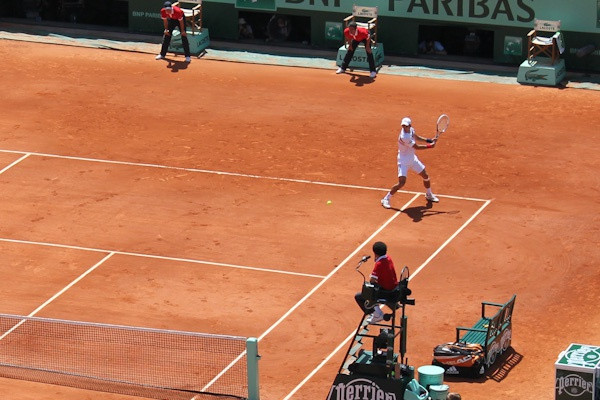Describe the objects in this image and their specific colors. I can see people in black, gray, salmon, red, and maroon tones, bench in black, maroon, gray, and teal tones, people in black, maroon, and salmon tones, chair in black, darkgray, maroon, and gray tones, and people in black, maroon, brown, and gray tones in this image. 